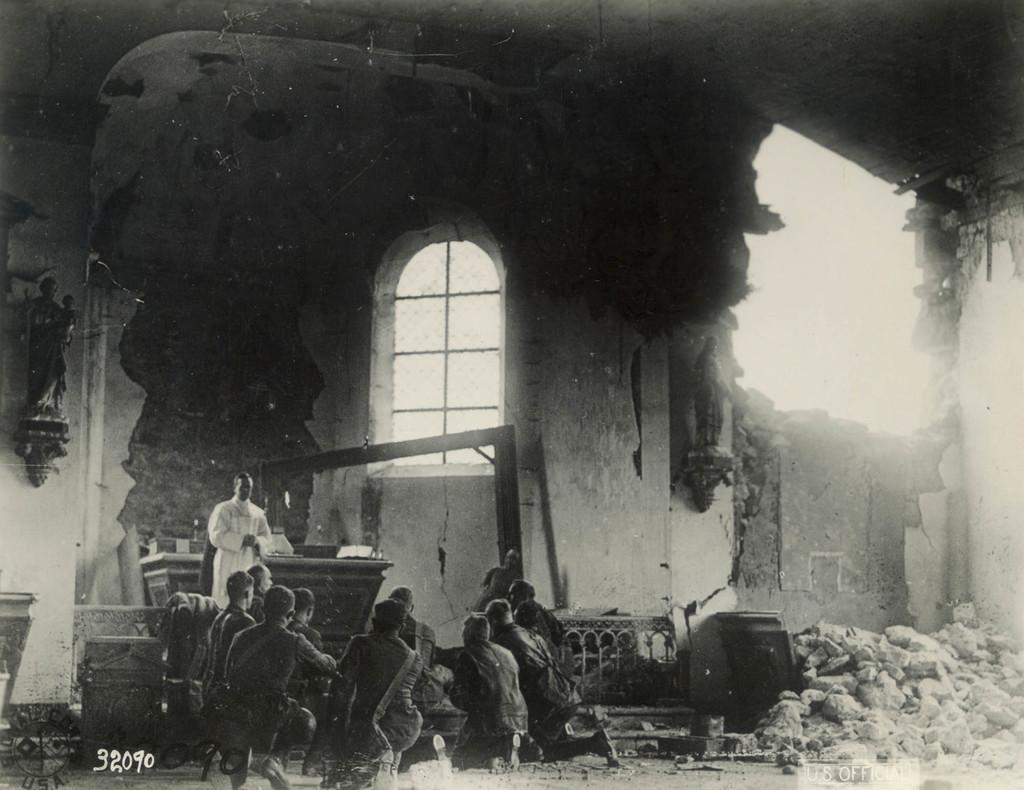Describe this image in one or two sentences. In this picture we can see a group of people, window, stones and in the background we can see wall. 